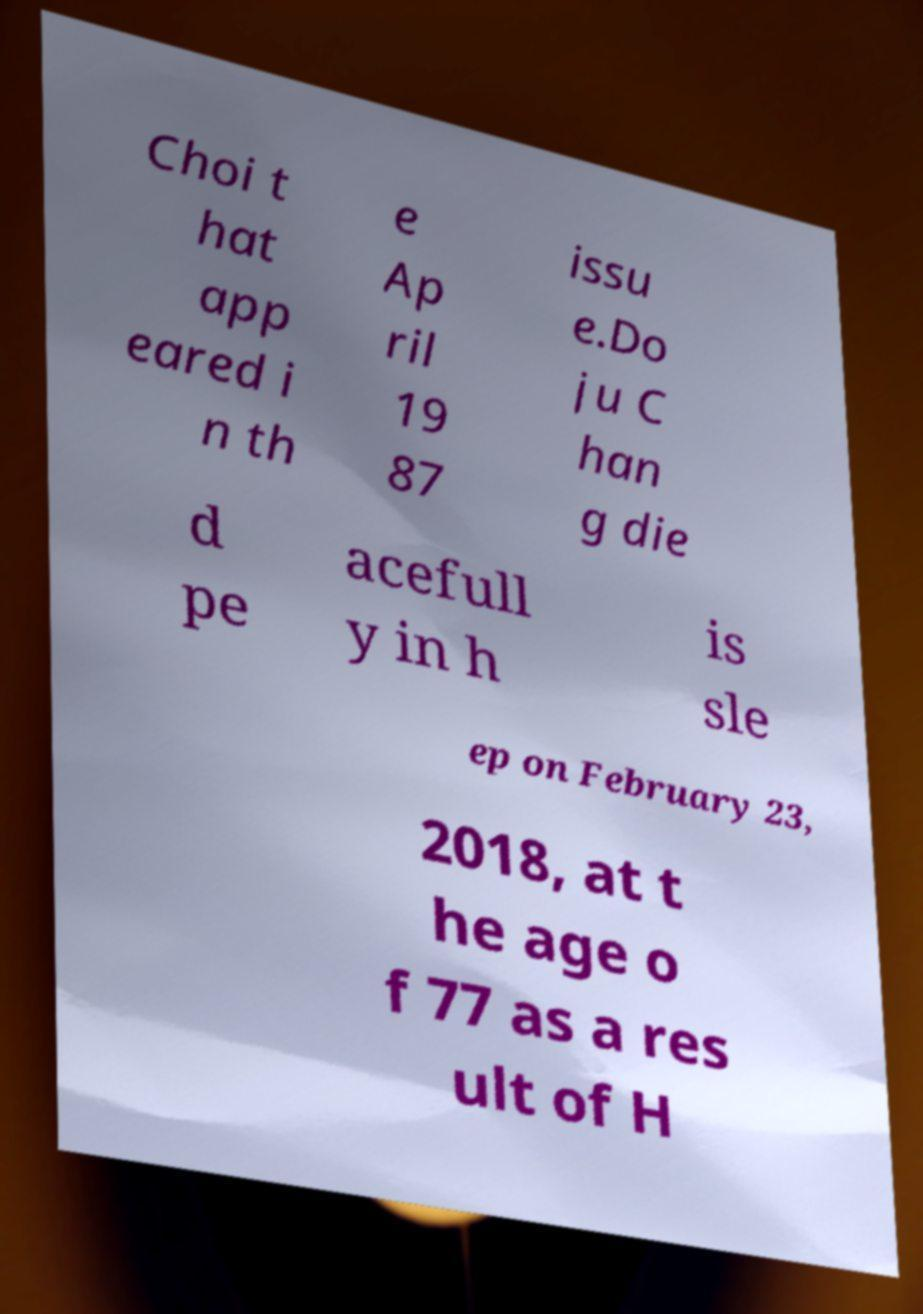Could you extract and type out the text from this image? Choi t hat app eared i n th e Ap ril 19 87 issu e.Do ju C han g die d pe acefull y in h is sle ep on February 23, 2018, at t he age o f 77 as a res ult of H 